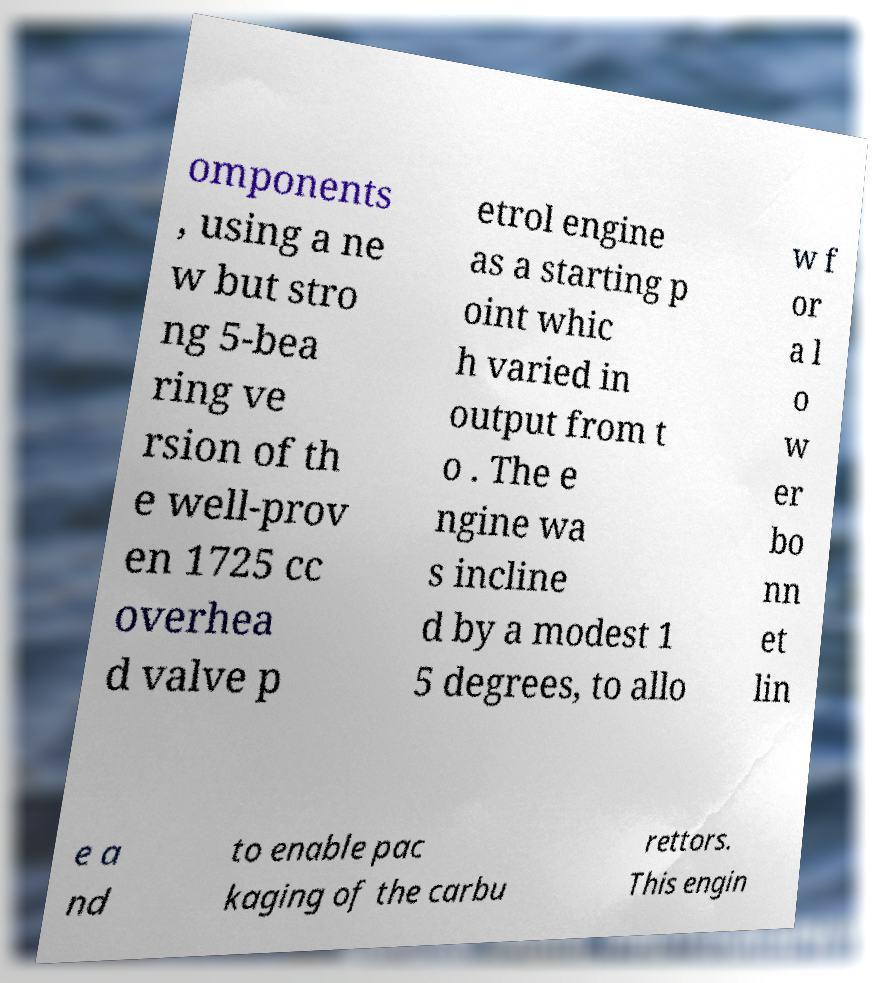Could you extract and type out the text from this image? omponents , using a ne w but stro ng 5-bea ring ve rsion of th e well-prov en 1725 cc overhea d valve p etrol engine as a starting p oint whic h varied in output from t o . The e ngine wa s incline d by a modest 1 5 degrees, to allo w f or a l o w er bo nn et lin e a nd to enable pac kaging of the carbu rettors. This engin 